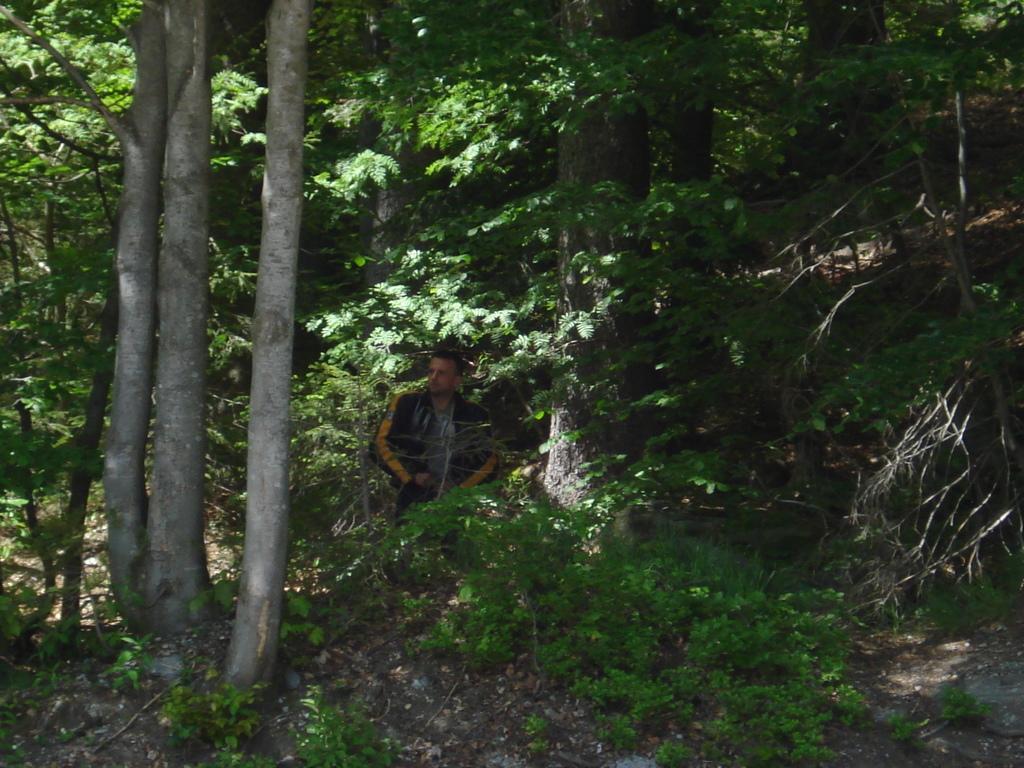Could you give a brief overview of what you see in this image? In this image we can see a man standing on the ground. In the background there are trees. 